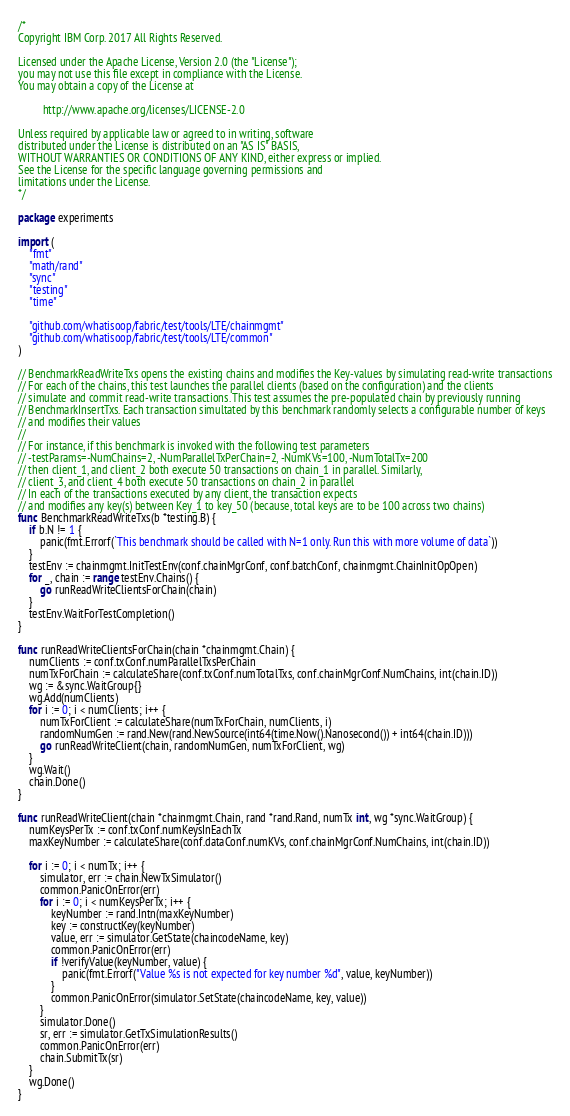<code> <loc_0><loc_0><loc_500><loc_500><_Go_>/*
Copyright IBM Corp. 2017 All Rights Reserved.

Licensed under the Apache License, Version 2.0 (the "License");
you may not use this file except in compliance with the License.
You may obtain a copy of the License at

		 http://www.apache.org/licenses/LICENSE-2.0

Unless required by applicable law or agreed to in writing, software
distributed under the License is distributed on an "AS IS" BASIS,
WITHOUT WARRANTIES OR CONDITIONS OF ANY KIND, either express or implied.
See the License for the specific language governing permissions and
limitations under the License.
*/

package experiments

import (
	"fmt"
	"math/rand"
	"sync"
	"testing"
	"time"

	"github.com/whatisoop/fabric/test/tools/LTE/chainmgmt"
	"github.com/whatisoop/fabric/test/tools/LTE/common"
)

// BenchmarkReadWriteTxs opens the existing chains and modifies the Key-values by simulating read-write transactions
// For each of the chains, this test launches the parallel clients (based on the configuration) and the clients
// simulate and commit read-write transactions. This test assumes the pre-populated chain by previously running
// BenchmarkInsertTxs. Each transaction simultated by this benchmark randomly selects a configurable number of keys
// and modifies their values
//
// For instance, if this benchmark is invoked with the following test parameters
// -testParams=-NumChains=2, -NumParallelTxPerChain=2, -NumKVs=100, -NumTotalTx=200
// then client_1, and client_2 both execute 50 transactions on chain_1 in parallel. Similarly,
// client_3, and client_4 both execute 50 transactions on chain_2 in parallel
// In each of the transactions executed by any client, the transaction expects
// and modifies any key(s) between Key_1 to key_50 (because, total keys are to be 100 across two chains)
func BenchmarkReadWriteTxs(b *testing.B) {
	if b.N != 1 {
		panic(fmt.Errorf(`This benchmark should be called with N=1 only. Run this with more volume of data`))
	}
	testEnv := chainmgmt.InitTestEnv(conf.chainMgrConf, conf.batchConf, chainmgmt.ChainInitOpOpen)
	for _, chain := range testEnv.Chains() {
		go runReadWriteClientsForChain(chain)
	}
	testEnv.WaitForTestCompletion()
}

func runReadWriteClientsForChain(chain *chainmgmt.Chain) {
	numClients := conf.txConf.numParallelTxsPerChain
	numTxForChain := calculateShare(conf.txConf.numTotalTxs, conf.chainMgrConf.NumChains, int(chain.ID))
	wg := &sync.WaitGroup{}
	wg.Add(numClients)
	for i := 0; i < numClients; i++ {
		numTxForClient := calculateShare(numTxForChain, numClients, i)
		randomNumGen := rand.New(rand.NewSource(int64(time.Now().Nanosecond()) + int64(chain.ID)))
		go runReadWriteClient(chain, randomNumGen, numTxForClient, wg)
	}
	wg.Wait()
	chain.Done()
}

func runReadWriteClient(chain *chainmgmt.Chain, rand *rand.Rand, numTx int, wg *sync.WaitGroup) {
	numKeysPerTx := conf.txConf.numKeysInEachTx
	maxKeyNumber := calculateShare(conf.dataConf.numKVs, conf.chainMgrConf.NumChains, int(chain.ID))

	for i := 0; i < numTx; i++ {
		simulator, err := chain.NewTxSimulator()
		common.PanicOnError(err)
		for i := 0; i < numKeysPerTx; i++ {
			keyNumber := rand.Intn(maxKeyNumber)
			key := constructKey(keyNumber)
			value, err := simulator.GetState(chaincodeName, key)
			common.PanicOnError(err)
			if !verifyValue(keyNumber, value) {
				panic(fmt.Errorf("Value %s is not expected for key number %d", value, keyNumber))
			}
			common.PanicOnError(simulator.SetState(chaincodeName, key, value))
		}
		simulator.Done()
		sr, err := simulator.GetTxSimulationResults()
		common.PanicOnError(err)
		chain.SubmitTx(sr)
	}
	wg.Done()
}
</code> 